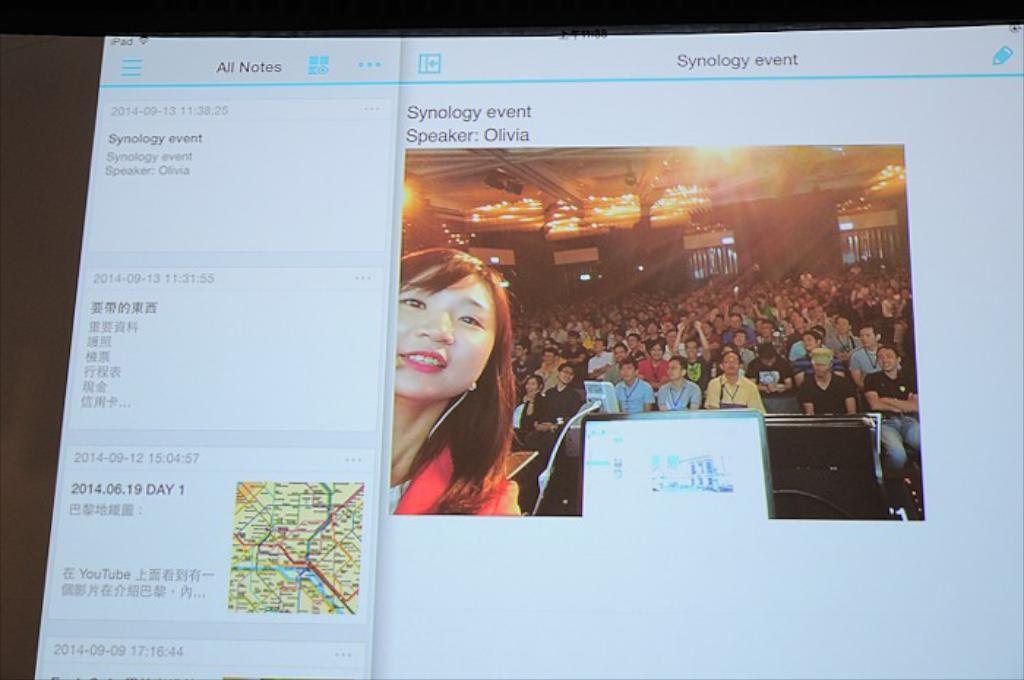What is the main object in the image? There is a screen in the image. What can be seen on the screen? A group of people is visible on the screen, along with a route map and some text. What color are the shoes worn by the people on the screen? There is no information about shoes or their color in the image. 